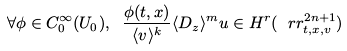Convert formula to latex. <formula><loc_0><loc_0><loc_500><loc_500>\forall \phi \in C _ { 0 } ^ { \infty } ( U _ { 0 } ) , \ \frac { \phi ( t , x ) } { \langle v \rangle ^ { k } } \langle D _ { z } \rangle ^ { m } u \in H ^ { r } ( \ r r _ { t , x , v } ^ { 2 n + 1 } )</formula> 